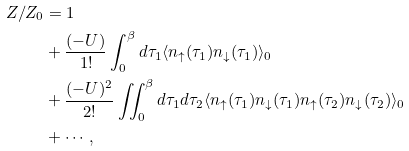<formula> <loc_0><loc_0><loc_500><loc_500>Z / Z _ { 0 } & = 1 \\ & + \frac { ( - U ) } { 1 ! } \int _ { 0 } ^ { \beta } d \tau _ { 1 } \langle n _ { \uparrow } ( \tau _ { 1 } ) n _ { \downarrow } ( \tau _ { 1 } ) \rangle _ { 0 } \\ & + \frac { ( - U ) ^ { 2 } } { 2 ! } \iint _ { 0 } ^ { \beta } d \tau _ { 1 } d \tau _ { 2 } \langle n _ { \uparrow } ( \tau _ { 1 } ) n _ { \downarrow } ( \tau _ { 1 } ) n _ { \uparrow } ( \tau _ { 2 } ) n _ { \downarrow } ( \tau _ { 2 } ) \rangle _ { 0 } \\ & + \cdots ,</formula> 